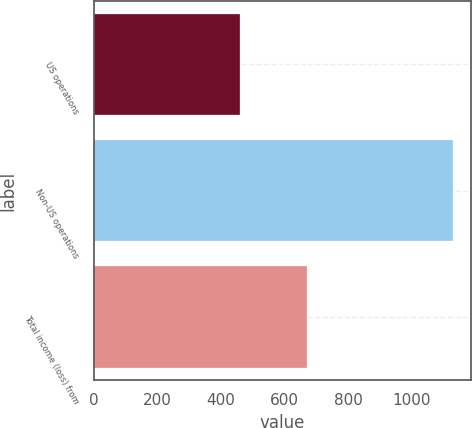Convert chart. <chart><loc_0><loc_0><loc_500><loc_500><bar_chart><fcel>US operations<fcel>Non-US operations<fcel>Total income (loss) from<nl><fcel>460<fcel>1130<fcel>670<nl></chart> 